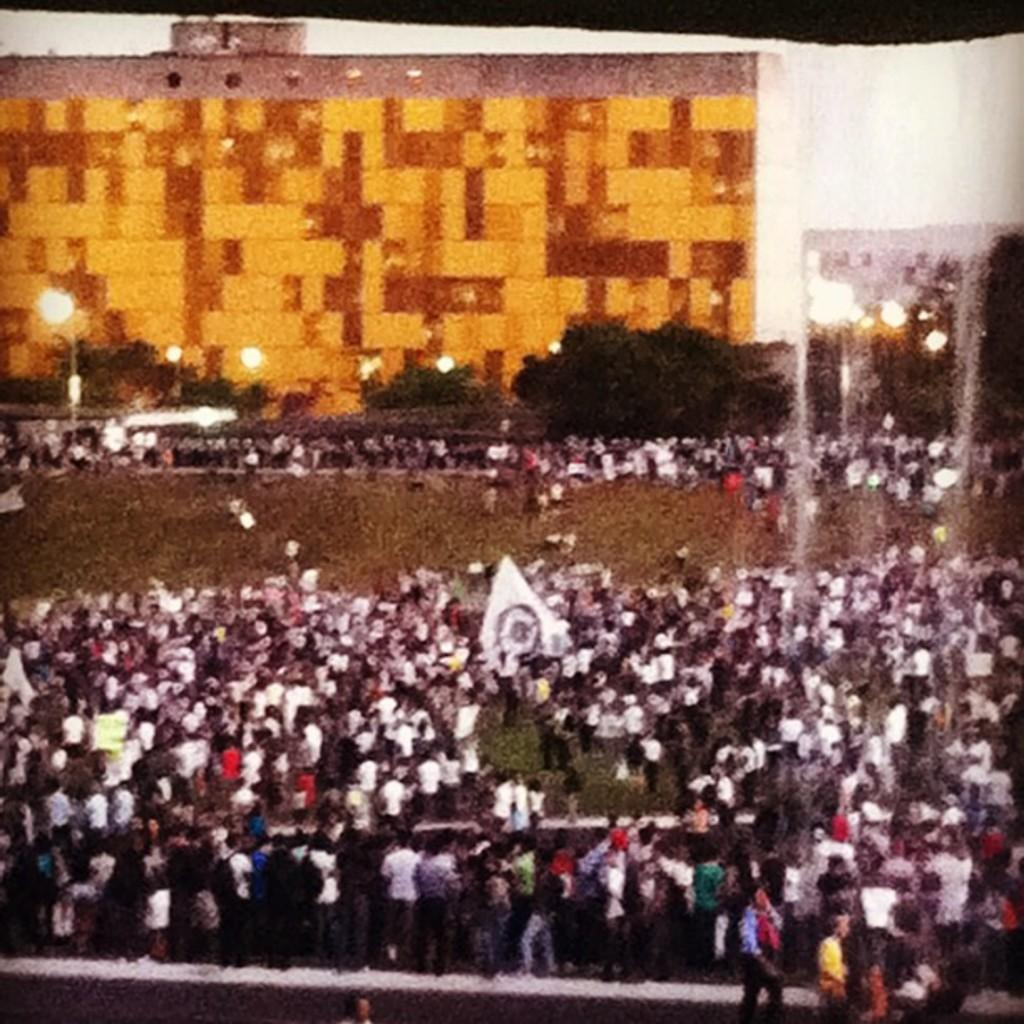What type of surface can be seen in the image? There is a ground in the image. What is the main feature of the image? There is a huge crowd of people in the image. What type of vegetation is present in the image? There is grass and trees in the image. What structures can be seen in the background of the image? There are buildings in the background of the image. What type of lighting is present in the image? There are street lights in the image. What part of the natural environment is visible in the image? The sky is visible in the image. How many branches can be seen on the horse in the image? There is no horse present in the image, so there are no branches to count. 